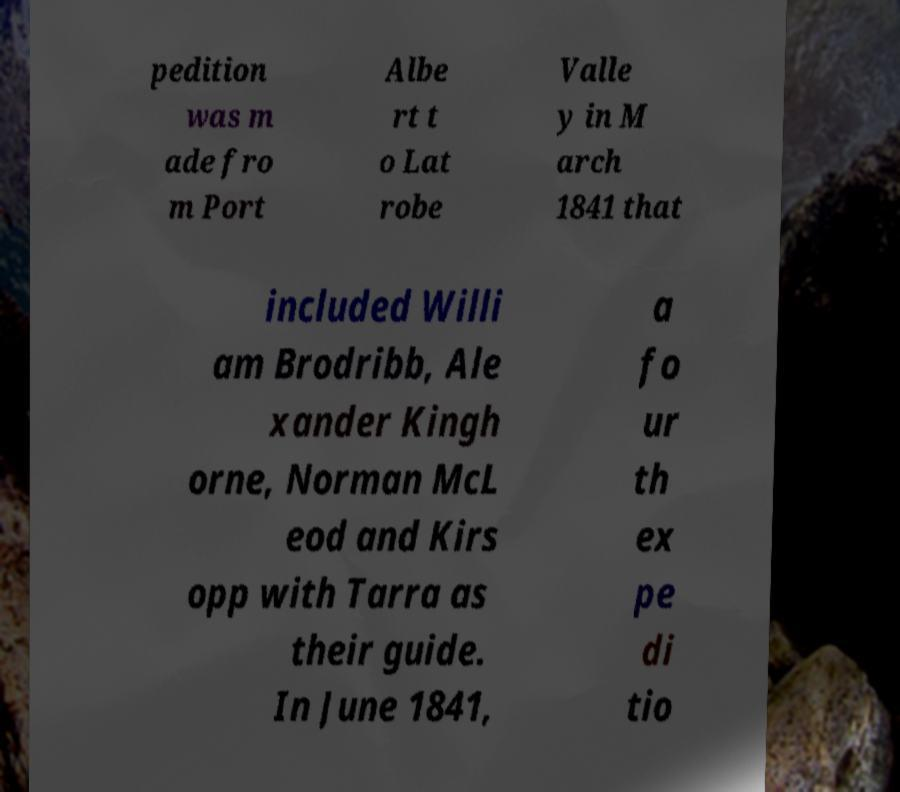Can you read and provide the text displayed in the image?This photo seems to have some interesting text. Can you extract and type it out for me? pedition was m ade fro m Port Albe rt t o Lat robe Valle y in M arch 1841 that included Willi am Brodribb, Ale xander Kingh orne, Norman McL eod and Kirs opp with Tarra as their guide. In June 1841, a fo ur th ex pe di tio 